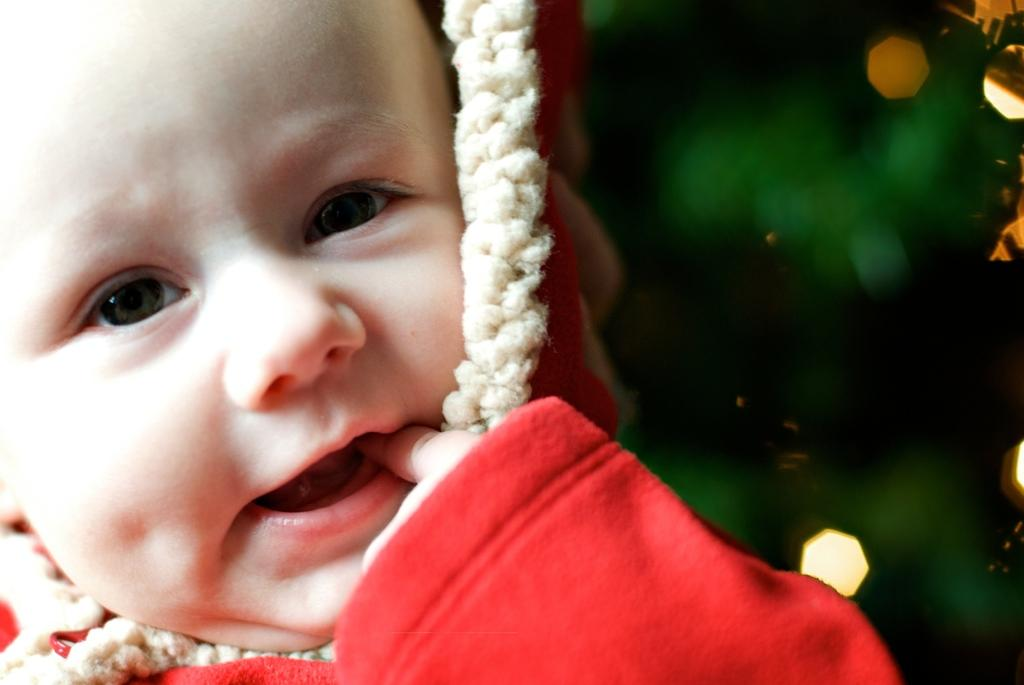What is the main subject of the picture? The main subject of the picture is a baby. What is the baby wearing in the picture? The baby is wearing a red-colored sweater. What is the baby doing with her hands in the picture? The baby has her fingers in her mouth. Can you see a kitten playing with a plane in the basket in the image? There is no kitten, plane, or basket present in the image; it only features a baby wearing a red-colored sweater and with her fingers in her mouth. 